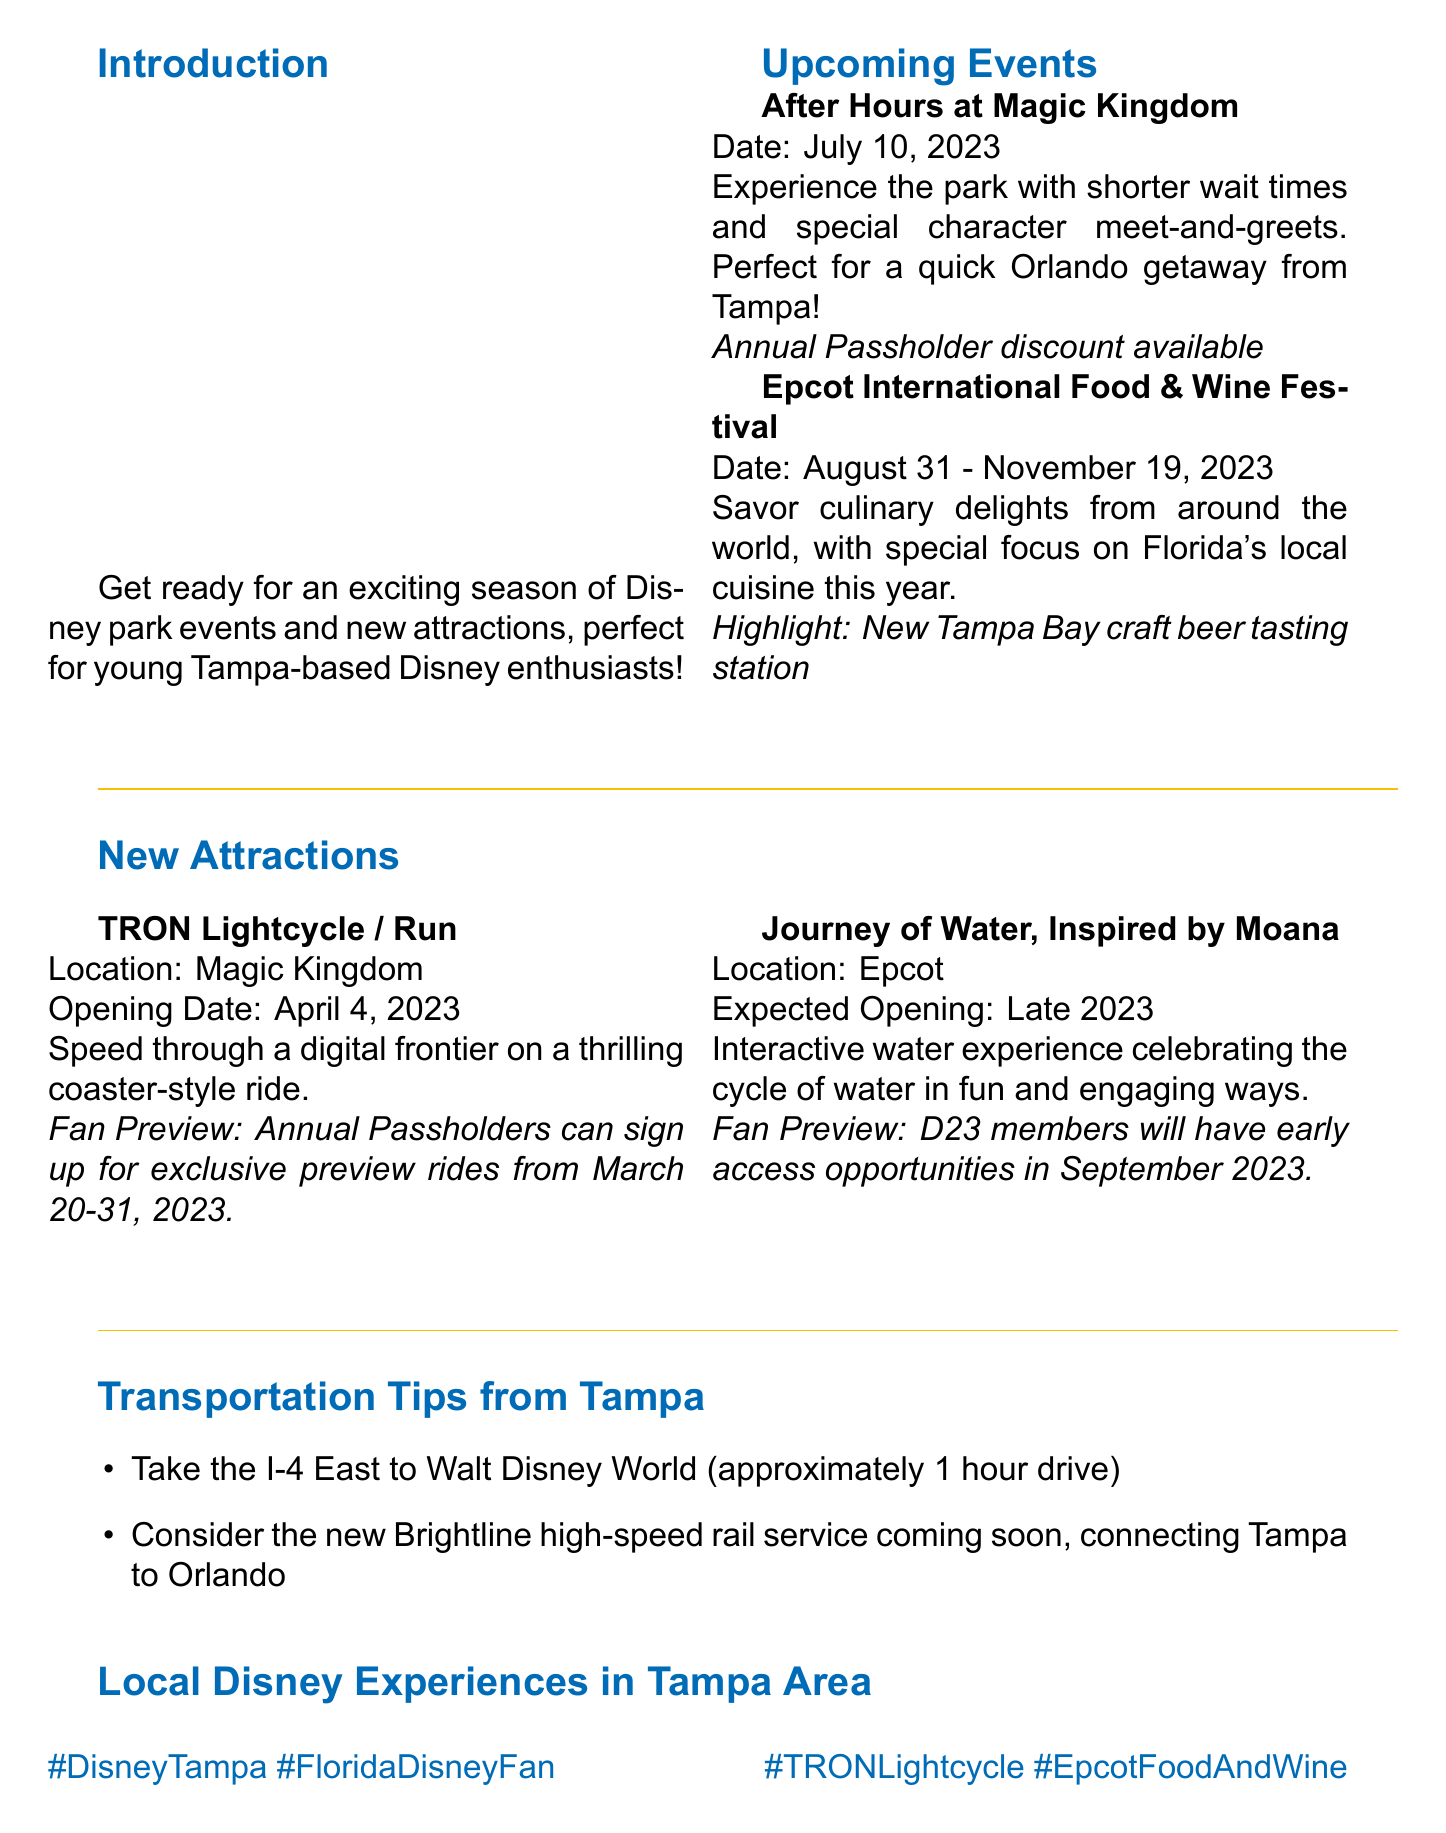what is the title of the newsletter? The title of the newsletter is explicitly stated in the document.
Answer: Disney Magic Insider: Tampa Edition when is the Epcot International Food & Wine Festival? The festival dates are included in the upcoming events section.
Answer: August 31 - November 19, 2023 what is the opening date of TRON Lightcycle / Run? The opening date is provided under the new attractions section.
Answer: April 4, 2023 what special highlight is mentioned for the Epcot International Food & Wine Festival? The highlight details are summarized in the upcoming events section.
Answer: New Tampa Bay craft beer tasting station who can sign up for exclusive preview rides for TRON Lightcycle / Run? This information is found in the fan preview notes for the new attraction.
Answer: Annual Passholders what is the expected opening timeframe for Journey of Water, Inspired by Moana? The expected opening is clearly stated in the new attractions section.
Answer: Late 2023 what is one of the transportation tips provided for getting to Walt Disney World from Tampa? The document contains specific transportation tips in a dedicated section.
Answer: Take the I-4 East to Walt Disney World where can you buy Disney merchandise in Tampa? The local experiences section lists a place for Disney merchandise.
Answer: Disney Store at International Plaza 